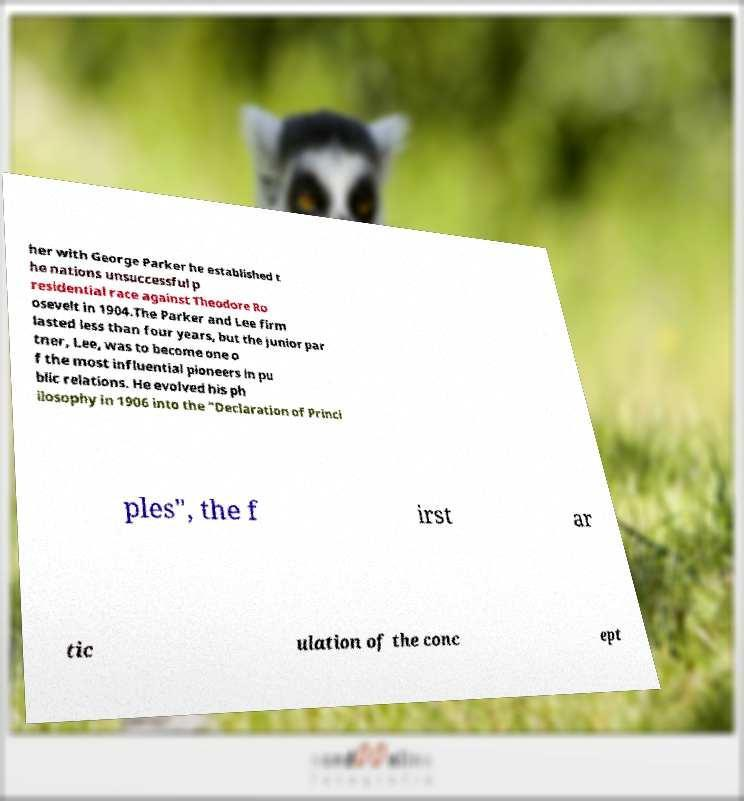For documentation purposes, I need the text within this image transcribed. Could you provide that? her with George Parker he established t he nations unsuccessful p residential race against Theodore Ro osevelt in 1904.The Parker and Lee firm lasted less than four years, but the junior par tner, Lee, was to become one o f the most influential pioneers in pu blic relations. He evolved his ph ilosophy in 1906 into the "Declaration of Princi ples", the f irst ar tic ulation of the conc ept 